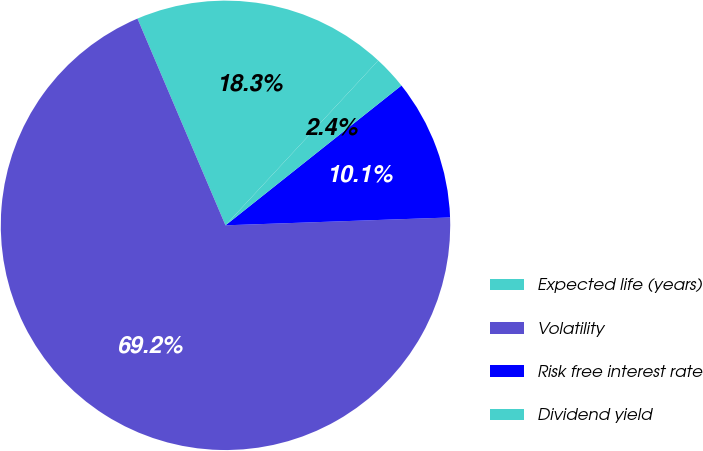Convert chart to OTSL. <chart><loc_0><loc_0><loc_500><loc_500><pie_chart><fcel>Expected life (years)<fcel>Volatility<fcel>Risk free interest rate<fcel>Dividend yield<nl><fcel>18.3%<fcel>69.15%<fcel>10.13%<fcel>2.42%<nl></chart> 